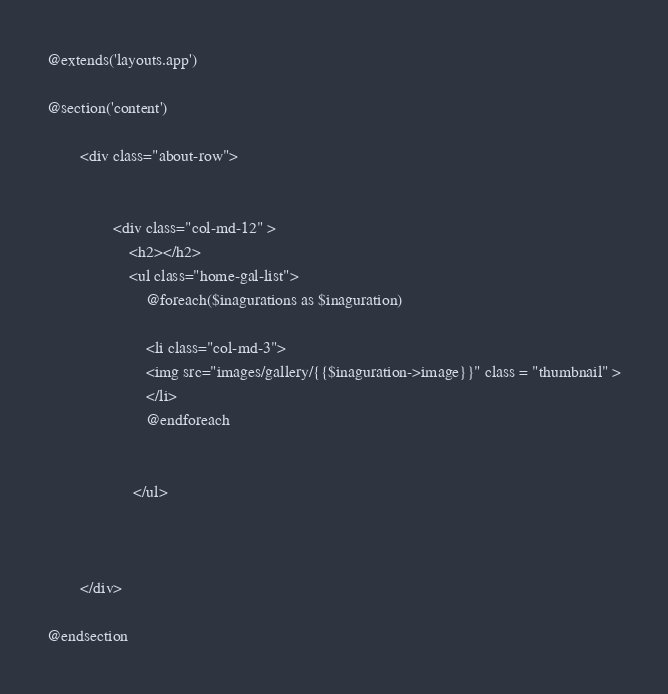Convert code to text. <code><loc_0><loc_0><loc_500><loc_500><_PHP_>@extends('layouts.app')

@section('content')

        <div class="about-row">
       
     
                <div class="col-md-12" >
                    <h2></h2>
                    <ul class="home-gal-list">
                        @foreach($inagurations as $inaguration)

                        <li class="col-md-3">
                        <img src="images/gallery/{{$inaguration->image}}" class = "thumbnail" >
                        </li>
                        @endforeach

                    
                     </ul>

                    

        </div>

@endsection
</code> 